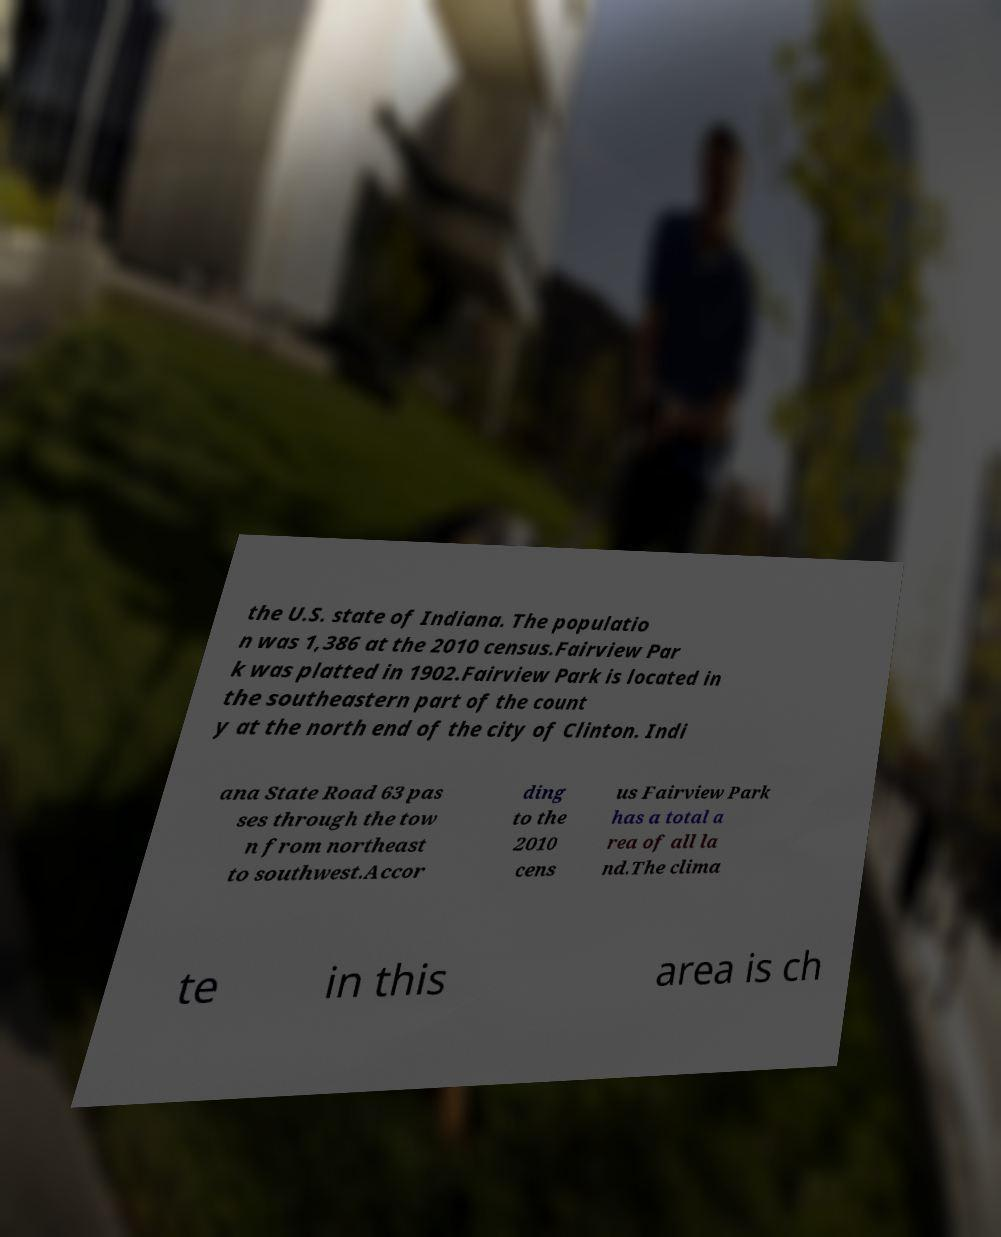What messages or text are displayed in this image? I need them in a readable, typed format. the U.S. state of Indiana. The populatio n was 1,386 at the 2010 census.Fairview Par k was platted in 1902.Fairview Park is located in the southeastern part of the count y at the north end of the city of Clinton. Indi ana State Road 63 pas ses through the tow n from northeast to southwest.Accor ding to the 2010 cens us Fairview Park has a total a rea of all la nd.The clima te in this area is ch 